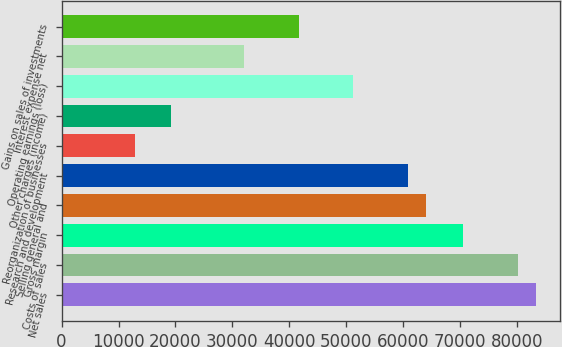<chart> <loc_0><loc_0><loc_500><loc_500><bar_chart><fcel>Net sales<fcel>Costs of sales<fcel>Gross margin<fcel>Selling general and<fcel>Research and development<fcel>Reorganization of businesses<fcel>Other charges (income)<fcel>Operating earnings (loss)<fcel>Interest expense net<fcel>Gains on sales of investments<nl><fcel>83319.2<fcel>80114.7<fcel>70500.9<fcel>64091.8<fcel>60887.2<fcel>12818.5<fcel>19227.6<fcel>51273.4<fcel>32046<fcel>41659.7<nl></chart> 